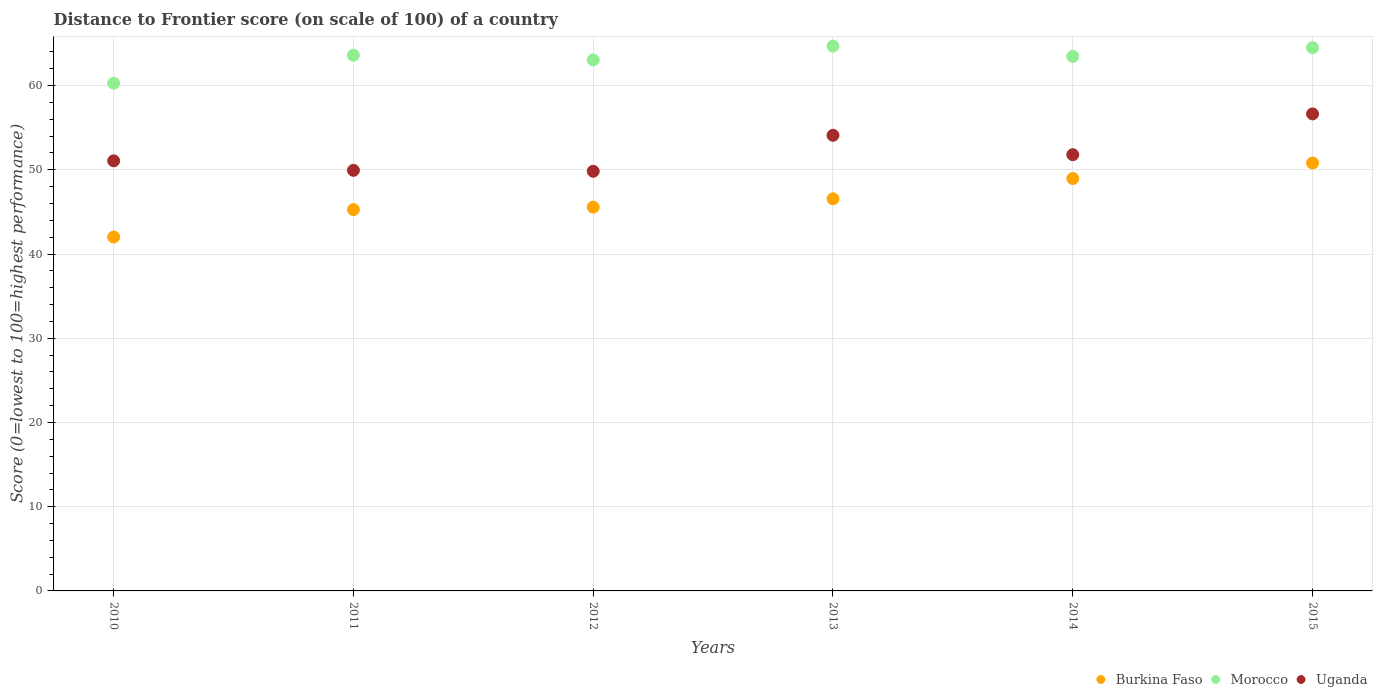What is the distance to frontier score of in Uganda in 2014?
Ensure brevity in your answer.  51.8. Across all years, what is the maximum distance to frontier score of in Morocco?
Offer a terse response. 64.69. Across all years, what is the minimum distance to frontier score of in Morocco?
Your response must be concise. 60.28. In which year was the distance to frontier score of in Uganda maximum?
Keep it short and to the point. 2015. What is the total distance to frontier score of in Uganda in the graph?
Keep it short and to the point. 313.38. What is the difference between the distance to frontier score of in Morocco in 2013 and that in 2014?
Give a very brief answer. 1.22. What is the difference between the distance to frontier score of in Uganda in 2015 and the distance to frontier score of in Morocco in 2010?
Your answer should be compact. -3.64. What is the average distance to frontier score of in Morocco per year?
Your response must be concise. 63.27. In the year 2010, what is the difference between the distance to frontier score of in Burkina Faso and distance to frontier score of in Uganda?
Provide a short and direct response. -9.05. What is the ratio of the distance to frontier score of in Morocco in 2011 to that in 2013?
Your answer should be very brief. 0.98. Is the difference between the distance to frontier score of in Burkina Faso in 2010 and 2015 greater than the difference between the distance to frontier score of in Uganda in 2010 and 2015?
Offer a very short reply. No. What is the difference between the highest and the second highest distance to frontier score of in Morocco?
Make the answer very short. 0.18. What is the difference between the highest and the lowest distance to frontier score of in Uganda?
Your answer should be very brief. 6.81. In how many years, is the distance to frontier score of in Uganda greater than the average distance to frontier score of in Uganda taken over all years?
Provide a short and direct response. 2. Does the distance to frontier score of in Uganda monotonically increase over the years?
Your response must be concise. No. Is the distance to frontier score of in Uganda strictly less than the distance to frontier score of in Burkina Faso over the years?
Offer a terse response. No. How many years are there in the graph?
Offer a very short reply. 6. Are the values on the major ticks of Y-axis written in scientific E-notation?
Your answer should be very brief. No. Does the graph contain any zero values?
Keep it short and to the point. No. How many legend labels are there?
Give a very brief answer. 3. What is the title of the graph?
Your response must be concise. Distance to Frontier score (on scale of 100) of a country. What is the label or title of the Y-axis?
Ensure brevity in your answer.  Score (0=lowest to 100=highest performance). What is the Score (0=lowest to 100=highest performance) in Burkina Faso in 2010?
Your answer should be very brief. 42.02. What is the Score (0=lowest to 100=highest performance) in Morocco in 2010?
Offer a terse response. 60.28. What is the Score (0=lowest to 100=highest performance) of Uganda in 2010?
Provide a short and direct response. 51.07. What is the Score (0=lowest to 100=highest performance) in Burkina Faso in 2011?
Offer a very short reply. 45.28. What is the Score (0=lowest to 100=highest performance) of Morocco in 2011?
Ensure brevity in your answer.  63.61. What is the Score (0=lowest to 100=highest performance) of Uganda in 2011?
Provide a short and direct response. 49.94. What is the Score (0=lowest to 100=highest performance) of Burkina Faso in 2012?
Make the answer very short. 45.57. What is the Score (0=lowest to 100=highest performance) of Morocco in 2012?
Your answer should be compact. 63.05. What is the Score (0=lowest to 100=highest performance) in Uganda in 2012?
Make the answer very short. 49.83. What is the Score (0=lowest to 100=highest performance) in Burkina Faso in 2013?
Give a very brief answer. 46.56. What is the Score (0=lowest to 100=highest performance) in Morocco in 2013?
Your answer should be very brief. 64.69. What is the Score (0=lowest to 100=highest performance) of Uganda in 2013?
Provide a short and direct response. 54.1. What is the Score (0=lowest to 100=highest performance) in Burkina Faso in 2014?
Your answer should be compact. 48.97. What is the Score (0=lowest to 100=highest performance) of Morocco in 2014?
Keep it short and to the point. 63.47. What is the Score (0=lowest to 100=highest performance) in Uganda in 2014?
Ensure brevity in your answer.  51.8. What is the Score (0=lowest to 100=highest performance) of Burkina Faso in 2015?
Ensure brevity in your answer.  50.81. What is the Score (0=lowest to 100=highest performance) of Morocco in 2015?
Provide a short and direct response. 64.51. What is the Score (0=lowest to 100=highest performance) in Uganda in 2015?
Provide a succinct answer. 56.64. Across all years, what is the maximum Score (0=lowest to 100=highest performance) of Burkina Faso?
Provide a short and direct response. 50.81. Across all years, what is the maximum Score (0=lowest to 100=highest performance) of Morocco?
Provide a succinct answer. 64.69. Across all years, what is the maximum Score (0=lowest to 100=highest performance) of Uganda?
Your answer should be very brief. 56.64. Across all years, what is the minimum Score (0=lowest to 100=highest performance) in Burkina Faso?
Keep it short and to the point. 42.02. Across all years, what is the minimum Score (0=lowest to 100=highest performance) in Morocco?
Offer a very short reply. 60.28. Across all years, what is the minimum Score (0=lowest to 100=highest performance) in Uganda?
Keep it short and to the point. 49.83. What is the total Score (0=lowest to 100=highest performance) of Burkina Faso in the graph?
Ensure brevity in your answer.  279.21. What is the total Score (0=lowest to 100=highest performance) of Morocco in the graph?
Offer a very short reply. 379.61. What is the total Score (0=lowest to 100=highest performance) in Uganda in the graph?
Your response must be concise. 313.38. What is the difference between the Score (0=lowest to 100=highest performance) of Burkina Faso in 2010 and that in 2011?
Ensure brevity in your answer.  -3.26. What is the difference between the Score (0=lowest to 100=highest performance) in Morocco in 2010 and that in 2011?
Ensure brevity in your answer.  -3.33. What is the difference between the Score (0=lowest to 100=highest performance) in Uganda in 2010 and that in 2011?
Provide a succinct answer. 1.13. What is the difference between the Score (0=lowest to 100=highest performance) of Burkina Faso in 2010 and that in 2012?
Your answer should be very brief. -3.55. What is the difference between the Score (0=lowest to 100=highest performance) in Morocco in 2010 and that in 2012?
Ensure brevity in your answer.  -2.77. What is the difference between the Score (0=lowest to 100=highest performance) in Uganda in 2010 and that in 2012?
Your answer should be compact. 1.24. What is the difference between the Score (0=lowest to 100=highest performance) in Burkina Faso in 2010 and that in 2013?
Your answer should be very brief. -4.54. What is the difference between the Score (0=lowest to 100=highest performance) in Morocco in 2010 and that in 2013?
Your answer should be very brief. -4.41. What is the difference between the Score (0=lowest to 100=highest performance) in Uganda in 2010 and that in 2013?
Make the answer very short. -3.03. What is the difference between the Score (0=lowest to 100=highest performance) in Burkina Faso in 2010 and that in 2014?
Your answer should be very brief. -6.95. What is the difference between the Score (0=lowest to 100=highest performance) of Morocco in 2010 and that in 2014?
Make the answer very short. -3.19. What is the difference between the Score (0=lowest to 100=highest performance) of Uganda in 2010 and that in 2014?
Your response must be concise. -0.73. What is the difference between the Score (0=lowest to 100=highest performance) in Burkina Faso in 2010 and that in 2015?
Provide a succinct answer. -8.79. What is the difference between the Score (0=lowest to 100=highest performance) in Morocco in 2010 and that in 2015?
Keep it short and to the point. -4.23. What is the difference between the Score (0=lowest to 100=highest performance) of Uganda in 2010 and that in 2015?
Offer a very short reply. -5.57. What is the difference between the Score (0=lowest to 100=highest performance) of Burkina Faso in 2011 and that in 2012?
Provide a short and direct response. -0.29. What is the difference between the Score (0=lowest to 100=highest performance) in Morocco in 2011 and that in 2012?
Provide a succinct answer. 0.56. What is the difference between the Score (0=lowest to 100=highest performance) of Uganda in 2011 and that in 2012?
Make the answer very short. 0.11. What is the difference between the Score (0=lowest to 100=highest performance) in Burkina Faso in 2011 and that in 2013?
Your answer should be very brief. -1.28. What is the difference between the Score (0=lowest to 100=highest performance) in Morocco in 2011 and that in 2013?
Make the answer very short. -1.08. What is the difference between the Score (0=lowest to 100=highest performance) of Uganda in 2011 and that in 2013?
Offer a very short reply. -4.16. What is the difference between the Score (0=lowest to 100=highest performance) of Burkina Faso in 2011 and that in 2014?
Ensure brevity in your answer.  -3.69. What is the difference between the Score (0=lowest to 100=highest performance) in Morocco in 2011 and that in 2014?
Offer a terse response. 0.14. What is the difference between the Score (0=lowest to 100=highest performance) of Uganda in 2011 and that in 2014?
Your response must be concise. -1.86. What is the difference between the Score (0=lowest to 100=highest performance) of Burkina Faso in 2011 and that in 2015?
Your answer should be compact. -5.53. What is the difference between the Score (0=lowest to 100=highest performance) in Burkina Faso in 2012 and that in 2013?
Offer a terse response. -0.99. What is the difference between the Score (0=lowest to 100=highest performance) of Morocco in 2012 and that in 2013?
Offer a very short reply. -1.64. What is the difference between the Score (0=lowest to 100=highest performance) in Uganda in 2012 and that in 2013?
Ensure brevity in your answer.  -4.27. What is the difference between the Score (0=lowest to 100=highest performance) in Burkina Faso in 2012 and that in 2014?
Offer a very short reply. -3.4. What is the difference between the Score (0=lowest to 100=highest performance) of Morocco in 2012 and that in 2014?
Your answer should be compact. -0.42. What is the difference between the Score (0=lowest to 100=highest performance) of Uganda in 2012 and that in 2014?
Offer a terse response. -1.97. What is the difference between the Score (0=lowest to 100=highest performance) in Burkina Faso in 2012 and that in 2015?
Keep it short and to the point. -5.24. What is the difference between the Score (0=lowest to 100=highest performance) of Morocco in 2012 and that in 2015?
Give a very brief answer. -1.46. What is the difference between the Score (0=lowest to 100=highest performance) of Uganda in 2012 and that in 2015?
Your answer should be compact. -6.81. What is the difference between the Score (0=lowest to 100=highest performance) of Burkina Faso in 2013 and that in 2014?
Give a very brief answer. -2.41. What is the difference between the Score (0=lowest to 100=highest performance) in Morocco in 2013 and that in 2014?
Your answer should be very brief. 1.22. What is the difference between the Score (0=lowest to 100=highest performance) of Uganda in 2013 and that in 2014?
Offer a terse response. 2.3. What is the difference between the Score (0=lowest to 100=highest performance) of Burkina Faso in 2013 and that in 2015?
Give a very brief answer. -4.25. What is the difference between the Score (0=lowest to 100=highest performance) of Morocco in 2013 and that in 2015?
Provide a short and direct response. 0.18. What is the difference between the Score (0=lowest to 100=highest performance) of Uganda in 2013 and that in 2015?
Your answer should be very brief. -2.54. What is the difference between the Score (0=lowest to 100=highest performance) in Burkina Faso in 2014 and that in 2015?
Offer a very short reply. -1.84. What is the difference between the Score (0=lowest to 100=highest performance) in Morocco in 2014 and that in 2015?
Give a very brief answer. -1.04. What is the difference between the Score (0=lowest to 100=highest performance) in Uganda in 2014 and that in 2015?
Ensure brevity in your answer.  -4.84. What is the difference between the Score (0=lowest to 100=highest performance) of Burkina Faso in 2010 and the Score (0=lowest to 100=highest performance) of Morocco in 2011?
Make the answer very short. -21.59. What is the difference between the Score (0=lowest to 100=highest performance) of Burkina Faso in 2010 and the Score (0=lowest to 100=highest performance) of Uganda in 2011?
Keep it short and to the point. -7.92. What is the difference between the Score (0=lowest to 100=highest performance) of Morocco in 2010 and the Score (0=lowest to 100=highest performance) of Uganda in 2011?
Your response must be concise. 10.34. What is the difference between the Score (0=lowest to 100=highest performance) in Burkina Faso in 2010 and the Score (0=lowest to 100=highest performance) in Morocco in 2012?
Keep it short and to the point. -21.03. What is the difference between the Score (0=lowest to 100=highest performance) of Burkina Faso in 2010 and the Score (0=lowest to 100=highest performance) of Uganda in 2012?
Give a very brief answer. -7.81. What is the difference between the Score (0=lowest to 100=highest performance) in Morocco in 2010 and the Score (0=lowest to 100=highest performance) in Uganda in 2012?
Ensure brevity in your answer.  10.45. What is the difference between the Score (0=lowest to 100=highest performance) of Burkina Faso in 2010 and the Score (0=lowest to 100=highest performance) of Morocco in 2013?
Your answer should be very brief. -22.67. What is the difference between the Score (0=lowest to 100=highest performance) in Burkina Faso in 2010 and the Score (0=lowest to 100=highest performance) in Uganda in 2013?
Provide a short and direct response. -12.08. What is the difference between the Score (0=lowest to 100=highest performance) of Morocco in 2010 and the Score (0=lowest to 100=highest performance) of Uganda in 2013?
Provide a succinct answer. 6.18. What is the difference between the Score (0=lowest to 100=highest performance) of Burkina Faso in 2010 and the Score (0=lowest to 100=highest performance) of Morocco in 2014?
Your answer should be compact. -21.45. What is the difference between the Score (0=lowest to 100=highest performance) of Burkina Faso in 2010 and the Score (0=lowest to 100=highest performance) of Uganda in 2014?
Give a very brief answer. -9.78. What is the difference between the Score (0=lowest to 100=highest performance) of Morocco in 2010 and the Score (0=lowest to 100=highest performance) of Uganda in 2014?
Your answer should be compact. 8.48. What is the difference between the Score (0=lowest to 100=highest performance) in Burkina Faso in 2010 and the Score (0=lowest to 100=highest performance) in Morocco in 2015?
Your answer should be very brief. -22.49. What is the difference between the Score (0=lowest to 100=highest performance) of Burkina Faso in 2010 and the Score (0=lowest to 100=highest performance) of Uganda in 2015?
Ensure brevity in your answer.  -14.62. What is the difference between the Score (0=lowest to 100=highest performance) in Morocco in 2010 and the Score (0=lowest to 100=highest performance) in Uganda in 2015?
Offer a very short reply. 3.64. What is the difference between the Score (0=lowest to 100=highest performance) of Burkina Faso in 2011 and the Score (0=lowest to 100=highest performance) of Morocco in 2012?
Your answer should be very brief. -17.77. What is the difference between the Score (0=lowest to 100=highest performance) in Burkina Faso in 2011 and the Score (0=lowest to 100=highest performance) in Uganda in 2012?
Your answer should be very brief. -4.55. What is the difference between the Score (0=lowest to 100=highest performance) in Morocco in 2011 and the Score (0=lowest to 100=highest performance) in Uganda in 2012?
Offer a terse response. 13.78. What is the difference between the Score (0=lowest to 100=highest performance) of Burkina Faso in 2011 and the Score (0=lowest to 100=highest performance) of Morocco in 2013?
Provide a short and direct response. -19.41. What is the difference between the Score (0=lowest to 100=highest performance) in Burkina Faso in 2011 and the Score (0=lowest to 100=highest performance) in Uganda in 2013?
Make the answer very short. -8.82. What is the difference between the Score (0=lowest to 100=highest performance) in Morocco in 2011 and the Score (0=lowest to 100=highest performance) in Uganda in 2013?
Ensure brevity in your answer.  9.51. What is the difference between the Score (0=lowest to 100=highest performance) in Burkina Faso in 2011 and the Score (0=lowest to 100=highest performance) in Morocco in 2014?
Offer a very short reply. -18.19. What is the difference between the Score (0=lowest to 100=highest performance) of Burkina Faso in 2011 and the Score (0=lowest to 100=highest performance) of Uganda in 2014?
Your response must be concise. -6.52. What is the difference between the Score (0=lowest to 100=highest performance) of Morocco in 2011 and the Score (0=lowest to 100=highest performance) of Uganda in 2014?
Your answer should be compact. 11.81. What is the difference between the Score (0=lowest to 100=highest performance) in Burkina Faso in 2011 and the Score (0=lowest to 100=highest performance) in Morocco in 2015?
Your answer should be compact. -19.23. What is the difference between the Score (0=lowest to 100=highest performance) in Burkina Faso in 2011 and the Score (0=lowest to 100=highest performance) in Uganda in 2015?
Make the answer very short. -11.36. What is the difference between the Score (0=lowest to 100=highest performance) in Morocco in 2011 and the Score (0=lowest to 100=highest performance) in Uganda in 2015?
Give a very brief answer. 6.97. What is the difference between the Score (0=lowest to 100=highest performance) of Burkina Faso in 2012 and the Score (0=lowest to 100=highest performance) of Morocco in 2013?
Provide a succinct answer. -19.12. What is the difference between the Score (0=lowest to 100=highest performance) in Burkina Faso in 2012 and the Score (0=lowest to 100=highest performance) in Uganda in 2013?
Provide a succinct answer. -8.53. What is the difference between the Score (0=lowest to 100=highest performance) in Morocco in 2012 and the Score (0=lowest to 100=highest performance) in Uganda in 2013?
Your answer should be compact. 8.95. What is the difference between the Score (0=lowest to 100=highest performance) of Burkina Faso in 2012 and the Score (0=lowest to 100=highest performance) of Morocco in 2014?
Offer a terse response. -17.9. What is the difference between the Score (0=lowest to 100=highest performance) of Burkina Faso in 2012 and the Score (0=lowest to 100=highest performance) of Uganda in 2014?
Provide a succinct answer. -6.23. What is the difference between the Score (0=lowest to 100=highest performance) of Morocco in 2012 and the Score (0=lowest to 100=highest performance) of Uganda in 2014?
Keep it short and to the point. 11.25. What is the difference between the Score (0=lowest to 100=highest performance) of Burkina Faso in 2012 and the Score (0=lowest to 100=highest performance) of Morocco in 2015?
Give a very brief answer. -18.94. What is the difference between the Score (0=lowest to 100=highest performance) in Burkina Faso in 2012 and the Score (0=lowest to 100=highest performance) in Uganda in 2015?
Give a very brief answer. -11.07. What is the difference between the Score (0=lowest to 100=highest performance) in Morocco in 2012 and the Score (0=lowest to 100=highest performance) in Uganda in 2015?
Give a very brief answer. 6.41. What is the difference between the Score (0=lowest to 100=highest performance) in Burkina Faso in 2013 and the Score (0=lowest to 100=highest performance) in Morocco in 2014?
Offer a very short reply. -16.91. What is the difference between the Score (0=lowest to 100=highest performance) of Burkina Faso in 2013 and the Score (0=lowest to 100=highest performance) of Uganda in 2014?
Offer a very short reply. -5.24. What is the difference between the Score (0=lowest to 100=highest performance) in Morocco in 2013 and the Score (0=lowest to 100=highest performance) in Uganda in 2014?
Your answer should be very brief. 12.89. What is the difference between the Score (0=lowest to 100=highest performance) of Burkina Faso in 2013 and the Score (0=lowest to 100=highest performance) of Morocco in 2015?
Your response must be concise. -17.95. What is the difference between the Score (0=lowest to 100=highest performance) in Burkina Faso in 2013 and the Score (0=lowest to 100=highest performance) in Uganda in 2015?
Your answer should be very brief. -10.08. What is the difference between the Score (0=lowest to 100=highest performance) in Morocco in 2013 and the Score (0=lowest to 100=highest performance) in Uganda in 2015?
Your response must be concise. 8.05. What is the difference between the Score (0=lowest to 100=highest performance) in Burkina Faso in 2014 and the Score (0=lowest to 100=highest performance) in Morocco in 2015?
Provide a succinct answer. -15.54. What is the difference between the Score (0=lowest to 100=highest performance) of Burkina Faso in 2014 and the Score (0=lowest to 100=highest performance) of Uganda in 2015?
Your answer should be very brief. -7.67. What is the difference between the Score (0=lowest to 100=highest performance) in Morocco in 2014 and the Score (0=lowest to 100=highest performance) in Uganda in 2015?
Give a very brief answer. 6.83. What is the average Score (0=lowest to 100=highest performance) in Burkina Faso per year?
Offer a very short reply. 46.53. What is the average Score (0=lowest to 100=highest performance) of Morocco per year?
Ensure brevity in your answer.  63.27. What is the average Score (0=lowest to 100=highest performance) in Uganda per year?
Provide a succinct answer. 52.23. In the year 2010, what is the difference between the Score (0=lowest to 100=highest performance) in Burkina Faso and Score (0=lowest to 100=highest performance) in Morocco?
Your answer should be compact. -18.26. In the year 2010, what is the difference between the Score (0=lowest to 100=highest performance) in Burkina Faso and Score (0=lowest to 100=highest performance) in Uganda?
Provide a short and direct response. -9.05. In the year 2010, what is the difference between the Score (0=lowest to 100=highest performance) in Morocco and Score (0=lowest to 100=highest performance) in Uganda?
Your answer should be very brief. 9.21. In the year 2011, what is the difference between the Score (0=lowest to 100=highest performance) of Burkina Faso and Score (0=lowest to 100=highest performance) of Morocco?
Give a very brief answer. -18.33. In the year 2011, what is the difference between the Score (0=lowest to 100=highest performance) of Burkina Faso and Score (0=lowest to 100=highest performance) of Uganda?
Your response must be concise. -4.66. In the year 2011, what is the difference between the Score (0=lowest to 100=highest performance) of Morocco and Score (0=lowest to 100=highest performance) of Uganda?
Your response must be concise. 13.67. In the year 2012, what is the difference between the Score (0=lowest to 100=highest performance) of Burkina Faso and Score (0=lowest to 100=highest performance) of Morocco?
Offer a terse response. -17.48. In the year 2012, what is the difference between the Score (0=lowest to 100=highest performance) of Burkina Faso and Score (0=lowest to 100=highest performance) of Uganda?
Give a very brief answer. -4.26. In the year 2012, what is the difference between the Score (0=lowest to 100=highest performance) in Morocco and Score (0=lowest to 100=highest performance) in Uganda?
Offer a terse response. 13.22. In the year 2013, what is the difference between the Score (0=lowest to 100=highest performance) of Burkina Faso and Score (0=lowest to 100=highest performance) of Morocco?
Provide a succinct answer. -18.13. In the year 2013, what is the difference between the Score (0=lowest to 100=highest performance) of Burkina Faso and Score (0=lowest to 100=highest performance) of Uganda?
Offer a very short reply. -7.54. In the year 2013, what is the difference between the Score (0=lowest to 100=highest performance) in Morocco and Score (0=lowest to 100=highest performance) in Uganda?
Your answer should be very brief. 10.59. In the year 2014, what is the difference between the Score (0=lowest to 100=highest performance) in Burkina Faso and Score (0=lowest to 100=highest performance) in Morocco?
Keep it short and to the point. -14.5. In the year 2014, what is the difference between the Score (0=lowest to 100=highest performance) of Burkina Faso and Score (0=lowest to 100=highest performance) of Uganda?
Make the answer very short. -2.83. In the year 2014, what is the difference between the Score (0=lowest to 100=highest performance) of Morocco and Score (0=lowest to 100=highest performance) of Uganda?
Give a very brief answer. 11.67. In the year 2015, what is the difference between the Score (0=lowest to 100=highest performance) in Burkina Faso and Score (0=lowest to 100=highest performance) in Morocco?
Make the answer very short. -13.7. In the year 2015, what is the difference between the Score (0=lowest to 100=highest performance) in Burkina Faso and Score (0=lowest to 100=highest performance) in Uganda?
Your answer should be compact. -5.83. In the year 2015, what is the difference between the Score (0=lowest to 100=highest performance) in Morocco and Score (0=lowest to 100=highest performance) in Uganda?
Your answer should be very brief. 7.87. What is the ratio of the Score (0=lowest to 100=highest performance) of Burkina Faso in 2010 to that in 2011?
Provide a short and direct response. 0.93. What is the ratio of the Score (0=lowest to 100=highest performance) in Morocco in 2010 to that in 2011?
Give a very brief answer. 0.95. What is the ratio of the Score (0=lowest to 100=highest performance) of Uganda in 2010 to that in 2011?
Provide a short and direct response. 1.02. What is the ratio of the Score (0=lowest to 100=highest performance) of Burkina Faso in 2010 to that in 2012?
Make the answer very short. 0.92. What is the ratio of the Score (0=lowest to 100=highest performance) in Morocco in 2010 to that in 2012?
Offer a terse response. 0.96. What is the ratio of the Score (0=lowest to 100=highest performance) in Uganda in 2010 to that in 2012?
Give a very brief answer. 1.02. What is the ratio of the Score (0=lowest to 100=highest performance) of Burkina Faso in 2010 to that in 2013?
Provide a succinct answer. 0.9. What is the ratio of the Score (0=lowest to 100=highest performance) in Morocco in 2010 to that in 2013?
Your response must be concise. 0.93. What is the ratio of the Score (0=lowest to 100=highest performance) of Uganda in 2010 to that in 2013?
Ensure brevity in your answer.  0.94. What is the ratio of the Score (0=lowest to 100=highest performance) of Burkina Faso in 2010 to that in 2014?
Your response must be concise. 0.86. What is the ratio of the Score (0=lowest to 100=highest performance) of Morocco in 2010 to that in 2014?
Make the answer very short. 0.95. What is the ratio of the Score (0=lowest to 100=highest performance) in Uganda in 2010 to that in 2014?
Keep it short and to the point. 0.99. What is the ratio of the Score (0=lowest to 100=highest performance) of Burkina Faso in 2010 to that in 2015?
Your response must be concise. 0.83. What is the ratio of the Score (0=lowest to 100=highest performance) of Morocco in 2010 to that in 2015?
Your answer should be compact. 0.93. What is the ratio of the Score (0=lowest to 100=highest performance) in Uganda in 2010 to that in 2015?
Give a very brief answer. 0.9. What is the ratio of the Score (0=lowest to 100=highest performance) in Burkina Faso in 2011 to that in 2012?
Ensure brevity in your answer.  0.99. What is the ratio of the Score (0=lowest to 100=highest performance) in Morocco in 2011 to that in 2012?
Your response must be concise. 1.01. What is the ratio of the Score (0=lowest to 100=highest performance) in Burkina Faso in 2011 to that in 2013?
Provide a short and direct response. 0.97. What is the ratio of the Score (0=lowest to 100=highest performance) of Morocco in 2011 to that in 2013?
Your answer should be very brief. 0.98. What is the ratio of the Score (0=lowest to 100=highest performance) of Burkina Faso in 2011 to that in 2014?
Offer a very short reply. 0.92. What is the ratio of the Score (0=lowest to 100=highest performance) of Uganda in 2011 to that in 2014?
Provide a short and direct response. 0.96. What is the ratio of the Score (0=lowest to 100=highest performance) of Burkina Faso in 2011 to that in 2015?
Your answer should be compact. 0.89. What is the ratio of the Score (0=lowest to 100=highest performance) in Uganda in 2011 to that in 2015?
Your response must be concise. 0.88. What is the ratio of the Score (0=lowest to 100=highest performance) of Burkina Faso in 2012 to that in 2013?
Provide a succinct answer. 0.98. What is the ratio of the Score (0=lowest to 100=highest performance) of Morocco in 2012 to that in 2013?
Your answer should be very brief. 0.97. What is the ratio of the Score (0=lowest to 100=highest performance) in Uganda in 2012 to that in 2013?
Your answer should be compact. 0.92. What is the ratio of the Score (0=lowest to 100=highest performance) of Burkina Faso in 2012 to that in 2014?
Ensure brevity in your answer.  0.93. What is the ratio of the Score (0=lowest to 100=highest performance) of Burkina Faso in 2012 to that in 2015?
Make the answer very short. 0.9. What is the ratio of the Score (0=lowest to 100=highest performance) in Morocco in 2012 to that in 2015?
Your response must be concise. 0.98. What is the ratio of the Score (0=lowest to 100=highest performance) in Uganda in 2012 to that in 2015?
Your answer should be compact. 0.88. What is the ratio of the Score (0=lowest to 100=highest performance) of Burkina Faso in 2013 to that in 2014?
Give a very brief answer. 0.95. What is the ratio of the Score (0=lowest to 100=highest performance) in Morocco in 2013 to that in 2014?
Keep it short and to the point. 1.02. What is the ratio of the Score (0=lowest to 100=highest performance) of Uganda in 2013 to that in 2014?
Provide a short and direct response. 1.04. What is the ratio of the Score (0=lowest to 100=highest performance) of Burkina Faso in 2013 to that in 2015?
Offer a terse response. 0.92. What is the ratio of the Score (0=lowest to 100=highest performance) in Uganda in 2013 to that in 2015?
Offer a terse response. 0.96. What is the ratio of the Score (0=lowest to 100=highest performance) in Burkina Faso in 2014 to that in 2015?
Offer a terse response. 0.96. What is the ratio of the Score (0=lowest to 100=highest performance) of Morocco in 2014 to that in 2015?
Your answer should be compact. 0.98. What is the ratio of the Score (0=lowest to 100=highest performance) in Uganda in 2014 to that in 2015?
Provide a short and direct response. 0.91. What is the difference between the highest and the second highest Score (0=lowest to 100=highest performance) of Burkina Faso?
Offer a very short reply. 1.84. What is the difference between the highest and the second highest Score (0=lowest to 100=highest performance) of Morocco?
Offer a terse response. 0.18. What is the difference between the highest and the second highest Score (0=lowest to 100=highest performance) in Uganda?
Keep it short and to the point. 2.54. What is the difference between the highest and the lowest Score (0=lowest to 100=highest performance) of Burkina Faso?
Keep it short and to the point. 8.79. What is the difference between the highest and the lowest Score (0=lowest to 100=highest performance) of Morocco?
Make the answer very short. 4.41. What is the difference between the highest and the lowest Score (0=lowest to 100=highest performance) in Uganda?
Provide a succinct answer. 6.81. 